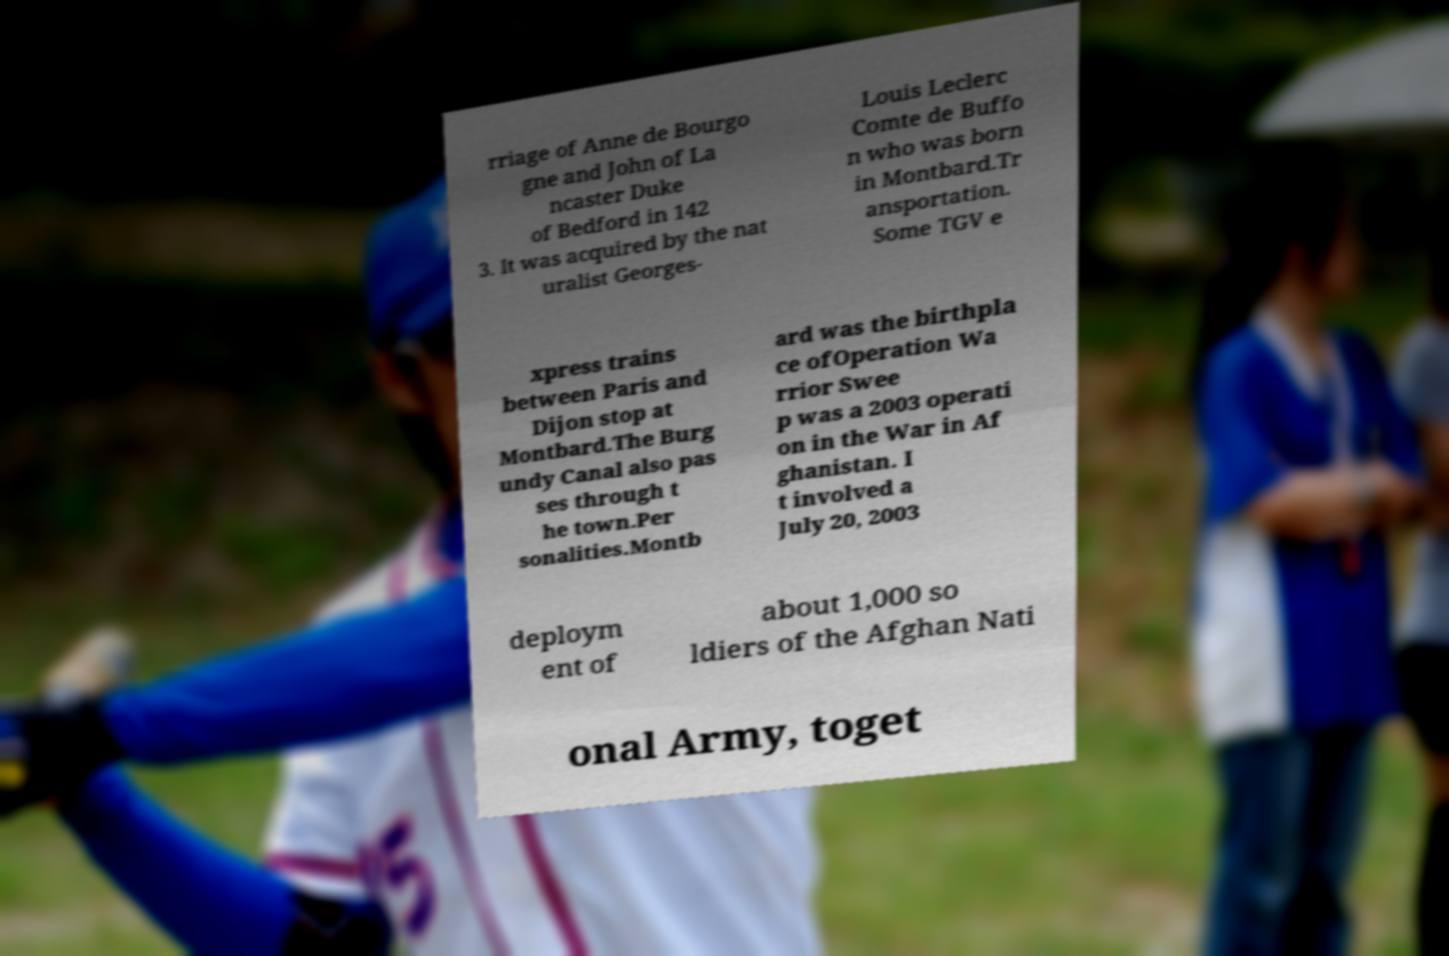Could you extract and type out the text from this image? rriage of Anne de Bourgo gne and John of La ncaster Duke of Bedford in 142 3. It was acquired by the nat uralist Georges- Louis Leclerc Comte de Buffo n who was born in Montbard.Tr ansportation. Some TGV e xpress trains between Paris and Dijon stop at Montbard.The Burg undy Canal also pas ses through t he town.Per sonalities.Montb ard was the birthpla ce ofOperation Wa rrior Swee p was a 2003 operati on in the War in Af ghanistan. I t involved a July 20, 2003 deploym ent of about 1,000 so ldiers of the Afghan Nati onal Army, toget 